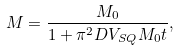<formula> <loc_0><loc_0><loc_500><loc_500>M = \frac { M _ { 0 } } { 1 + \pi ^ { 2 } D V _ { S Q } M _ { 0 } t } ,</formula> 